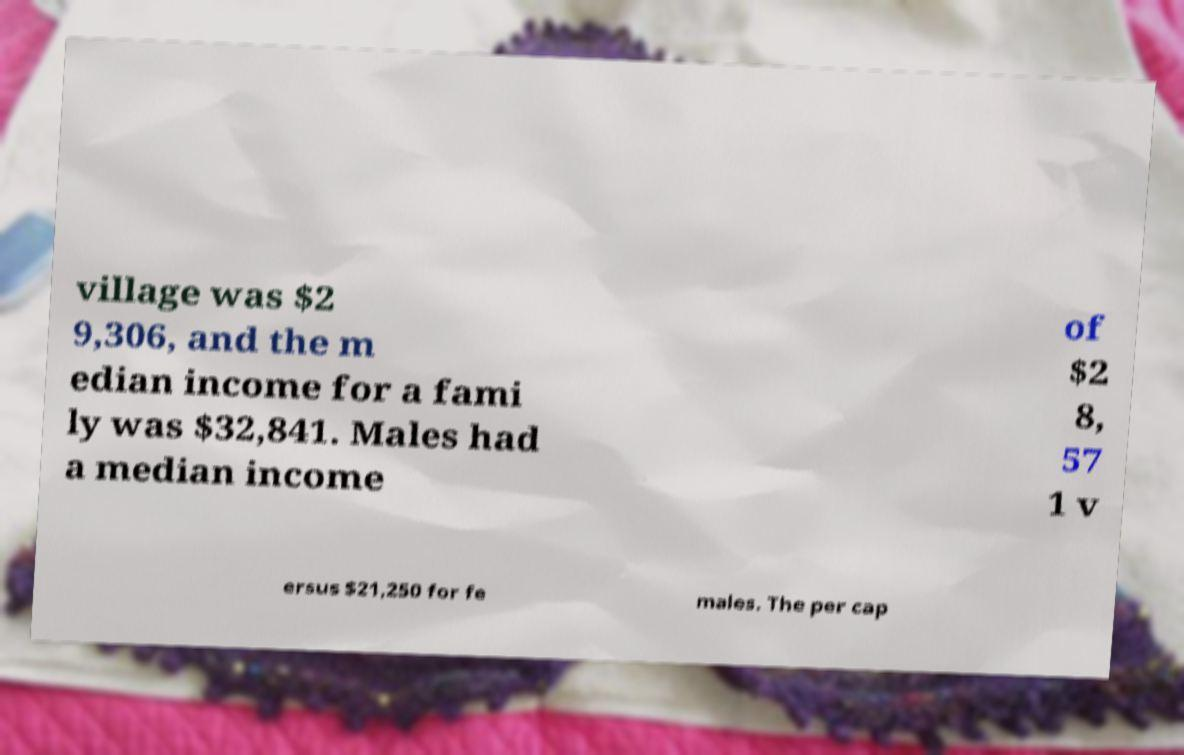I need the written content from this picture converted into text. Can you do that? village was $2 9,306, and the m edian income for a fami ly was $32,841. Males had a median income of $2 8, 57 1 v ersus $21,250 for fe males. The per cap 